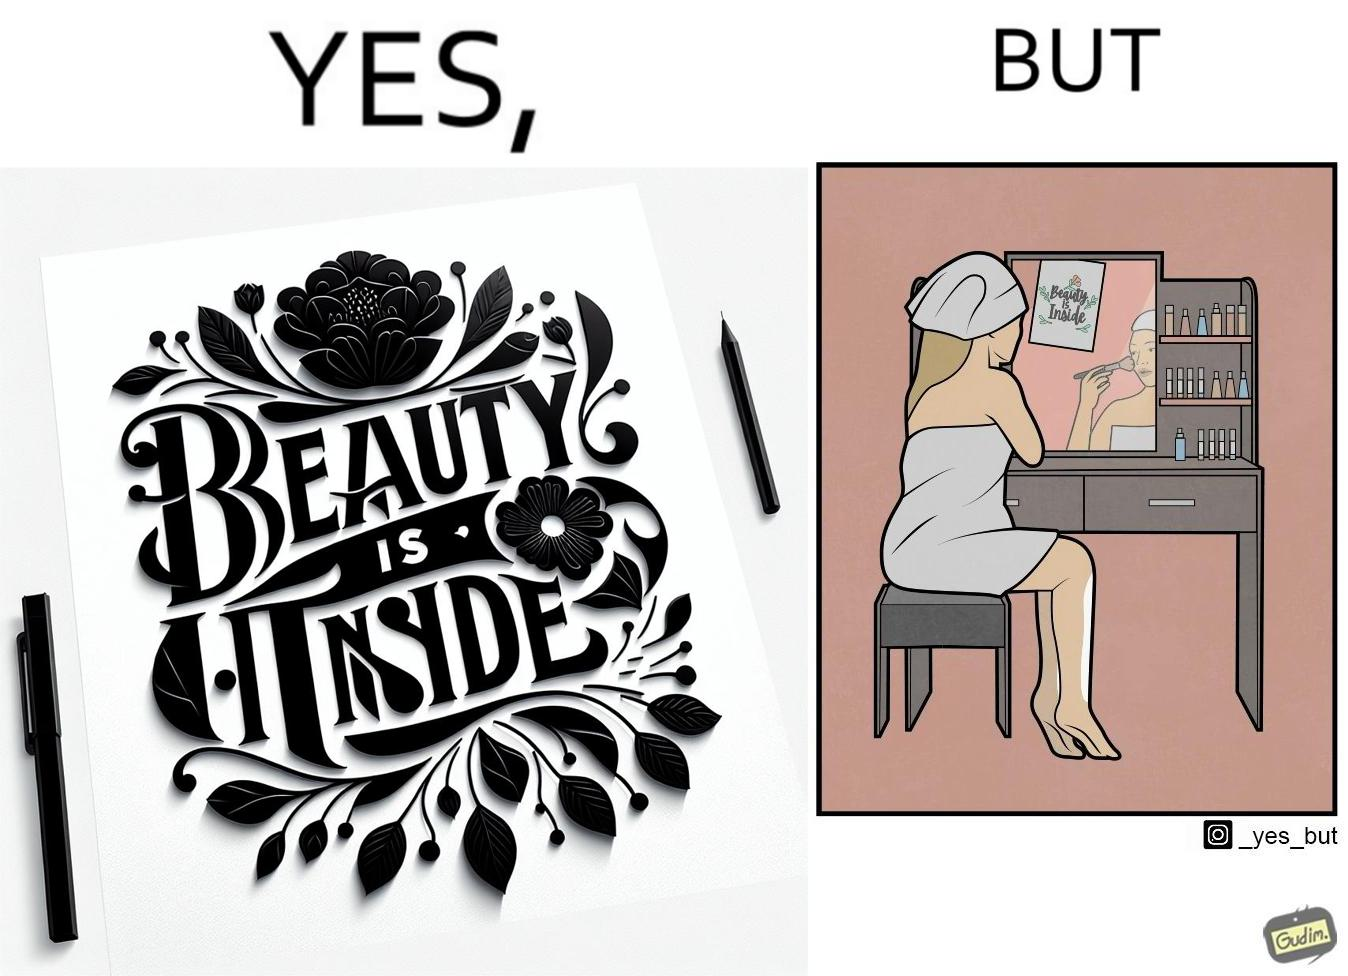Explain the humor or irony in this image. The image is satirical because while the text on the paper says that beauty lies inside, the woman ignores the note and continues to apply makeup to improve her outer beauty. 